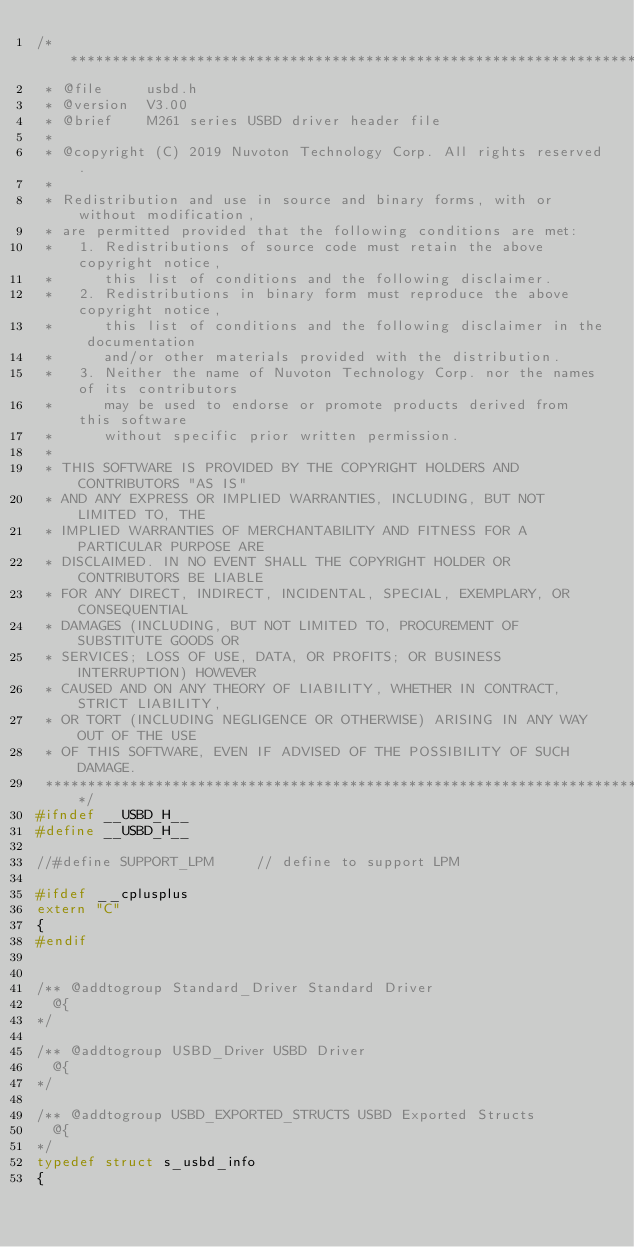Convert code to text. <code><loc_0><loc_0><loc_500><loc_500><_C_>/******************************************************************************
 * @file     usbd.h
 * @version  V3.00
 * @brief    M261 series USBD driver header file
 *
 * @copyright (C) 2019 Nuvoton Technology Corp. All rights reserved.
 * 
 * Redistribution and use in source and binary forms, with or without modification,
 * are permitted provided that the following conditions are met:
 *   1. Redistributions of source code must retain the above copyright notice,
 *      this list of conditions and the following disclaimer.
 *   2. Redistributions in binary form must reproduce the above copyright notice,
 *      this list of conditions and the following disclaimer in the documentation
 *      and/or other materials provided with the distribution.
 *   3. Neither the name of Nuvoton Technology Corp. nor the names of its contributors
 *      may be used to endorse or promote products derived from this software
 *      without specific prior written permission.
 * 
 * THIS SOFTWARE IS PROVIDED BY THE COPYRIGHT HOLDERS AND CONTRIBUTORS "AS IS"
 * AND ANY EXPRESS OR IMPLIED WARRANTIES, INCLUDING, BUT NOT LIMITED TO, THE
 * IMPLIED WARRANTIES OF MERCHANTABILITY AND FITNESS FOR A PARTICULAR PURPOSE ARE
 * DISCLAIMED. IN NO EVENT SHALL THE COPYRIGHT HOLDER OR CONTRIBUTORS BE LIABLE
 * FOR ANY DIRECT, INDIRECT, INCIDENTAL, SPECIAL, EXEMPLARY, OR CONSEQUENTIAL
 * DAMAGES (INCLUDING, BUT NOT LIMITED TO, PROCUREMENT OF SUBSTITUTE GOODS OR
 * SERVICES; LOSS OF USE, DATA, OR PROFITS; OR BUSINESS INTERRUPTION) HOWEVER
 * CAUSED AND ON ANY THEORY OF LIABILITY, WHETHER IN CONTRACT, STRICT LIABILITY,
 * OR TORT (INCLUDING NEGLIGENCE OR OTHERWISE) ARISING IN ANY WAY OUT OF THE USE
 * OF THIS SOFTWARE, EVEN IF ADVISED OF THE POSSIBILITY OF SUCH DAMAGE.
 ******************************************************************************/
#ifndef __USBD_H__
#define __USBD_H__

//#define SUPPORT_LPM     // define to support LPM

#ifdef __cplusplus
extern "C"
{
#endif


/** @addtogroup Standard_Driver Standard Driver
  @{
*/

/** @addtogroup USBD_Driver USBD Driver
  @{
*/

/** @addtogroup USBD_EXPORTED_STRUCTS USBD Exported Structs
  @{
*/
typedef struct s_usbd_info
{</code> 